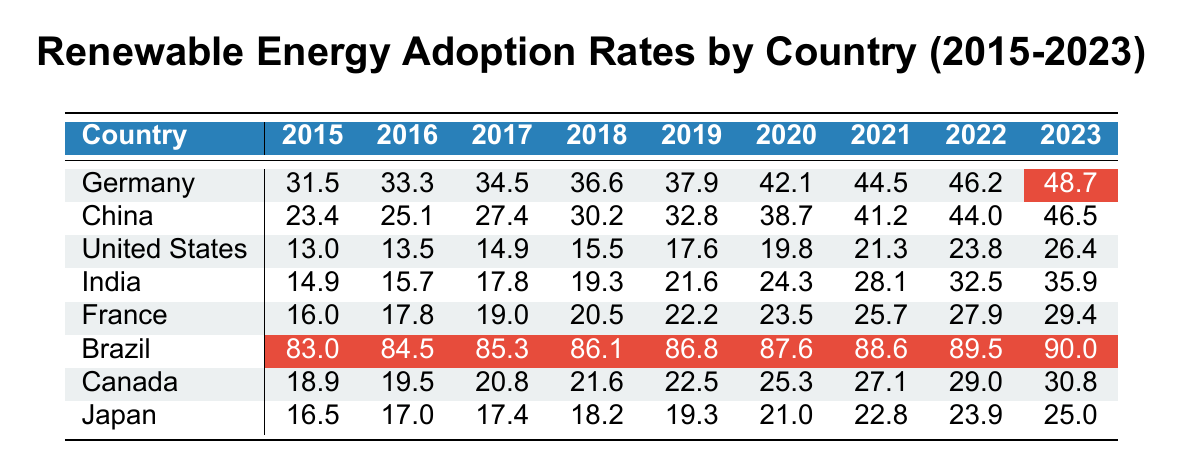What was the renewable energy adoption rate in Germany in 2023? Referring to the table, the adoption rate for Germany in 2023 is highlighted, indicating that it is equal to 48.7.
Answer: 48.7 Which country had the highest renewable energy adoption rate in 2015? By checking the 2015 column for all countries, Brazil shows the highest value at 83.0, compared to the other countries listed.
Answer: Brazil What is the average renewable energy adoption rate in India from 2015 to 2023? To find the average for India, sum the values from 2015 to 2023 (14.9 + 15.7 + 17.8 + 19.3 + 21.6 + 24.3 + 28.1 + 32.5 + 35.9 =  210.1) and divide by the number of years (9). Thus, the average is approximately 210.1 / 9 = 23.34.
Answer: 23.34 Did the United States have a higher renewable energy adoption rate than France in 2021? In the 2021 column, the United States shows a rate of 21.3, while France has a rate of 25.7. Since 21.3 is less than 25.7, the statement is false.
Answer: No What was the increase in renewable energy adoption rate for China from 2015 to 2023? The rate in 2015 for China is 23.4 and in 2023 it is 46.5. To find the increase, subtract the 2015 rate from the 2023 rate (46.5 - 23.4 = 23.1).
Answer: 23.1 Which country showed the most significant increase in renewable energy adoption rates from 2015 to 2023? Looking at the change from 2015 to 2023 for each country: Germany (17.2), China (23.1), United States (13.4), India (21.0), France (13.4), Brazil (7.0), Canada (11.9), Japan (8.5). China had the highest increase of 23.1.
Answer: China Is the renewable energy adoption rate in Canada in 2022 greater than that in Japan in 2023? Checking the values, Canada has a rate of 29.0 in 2022 while Japan has a rate of 25.0 in 2023. Since 29.0 is greater than 25.0, the statement is true.
Answer: Yes Calculate the total renewable energy adoption rate for all countries in 2023. Summing the 2023 values: (48.7 for Germany + 46.5 for China + 26.4 for United States + 35.9 for India + 29.4 for France + 90.0 for Brazil + 30.8 for Canada + 25.0 for Japan) gives a total of 332.7.
Answer: 332.7 What was the renewable energy adoption rate in Brazil in 2018? Referring to the table, Brazil’s rate in 2018 is 86.1.
Answer: 86.1 Was the renewable energy adoption rate in France in 2019 lower than that in the United States in 2022? France’s rate in 2019 is 22.2, and the United States’ rate in 2022 is 23.8. Since 22.2 is less than 23.8, the statement is true.
Answer: Yes What is the difference in renewable energy adoption rate between Germany and Canada in 2021? Germany has a rate of 44.5 and Canada a rate of 27.1 in 2021. The difference is 44.5 - 27.1 = 17.4.
Answer: 17.4 